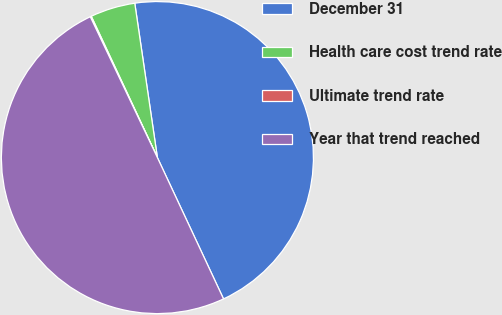<chart> <loc_0><loc_0><loc_500><loc_500><pie_chart><fcel>December 31<fcel>Health care cost trend rate<fcel>Ultimate trend rate<fcel>Year that trend reached<nl><fcel>45.35%<fcel>4.65%<fcel>0.11%<fcel>49.89%<nl></chart> 